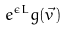<formula> <loc_0><loc_0><loc_500><loc_500>e ^ { \epsilon L } g ( \vec { v } )</formula> 